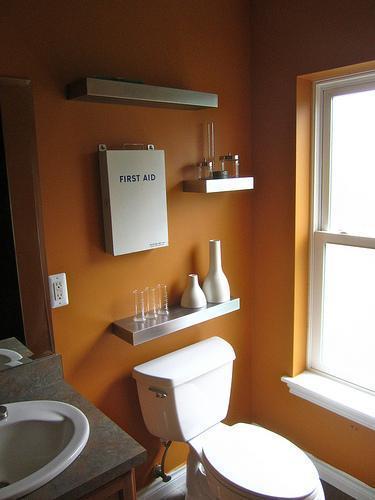How many small, tube shaped, glass vials are visible?
Give a very brief answer. 3. 